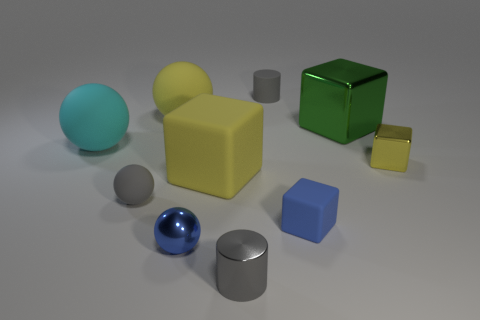How does the light source in the scene affect the appearance of the objects? The light source casts soft shadows and highlights on the objects, enhancing their three-dimensional appearance. The glossy objects, like the spheres and some of the blocks, reflect the light more intensely, while the matte surfaces, such as the yellow block, diffuse the light, giving them a softer look. 